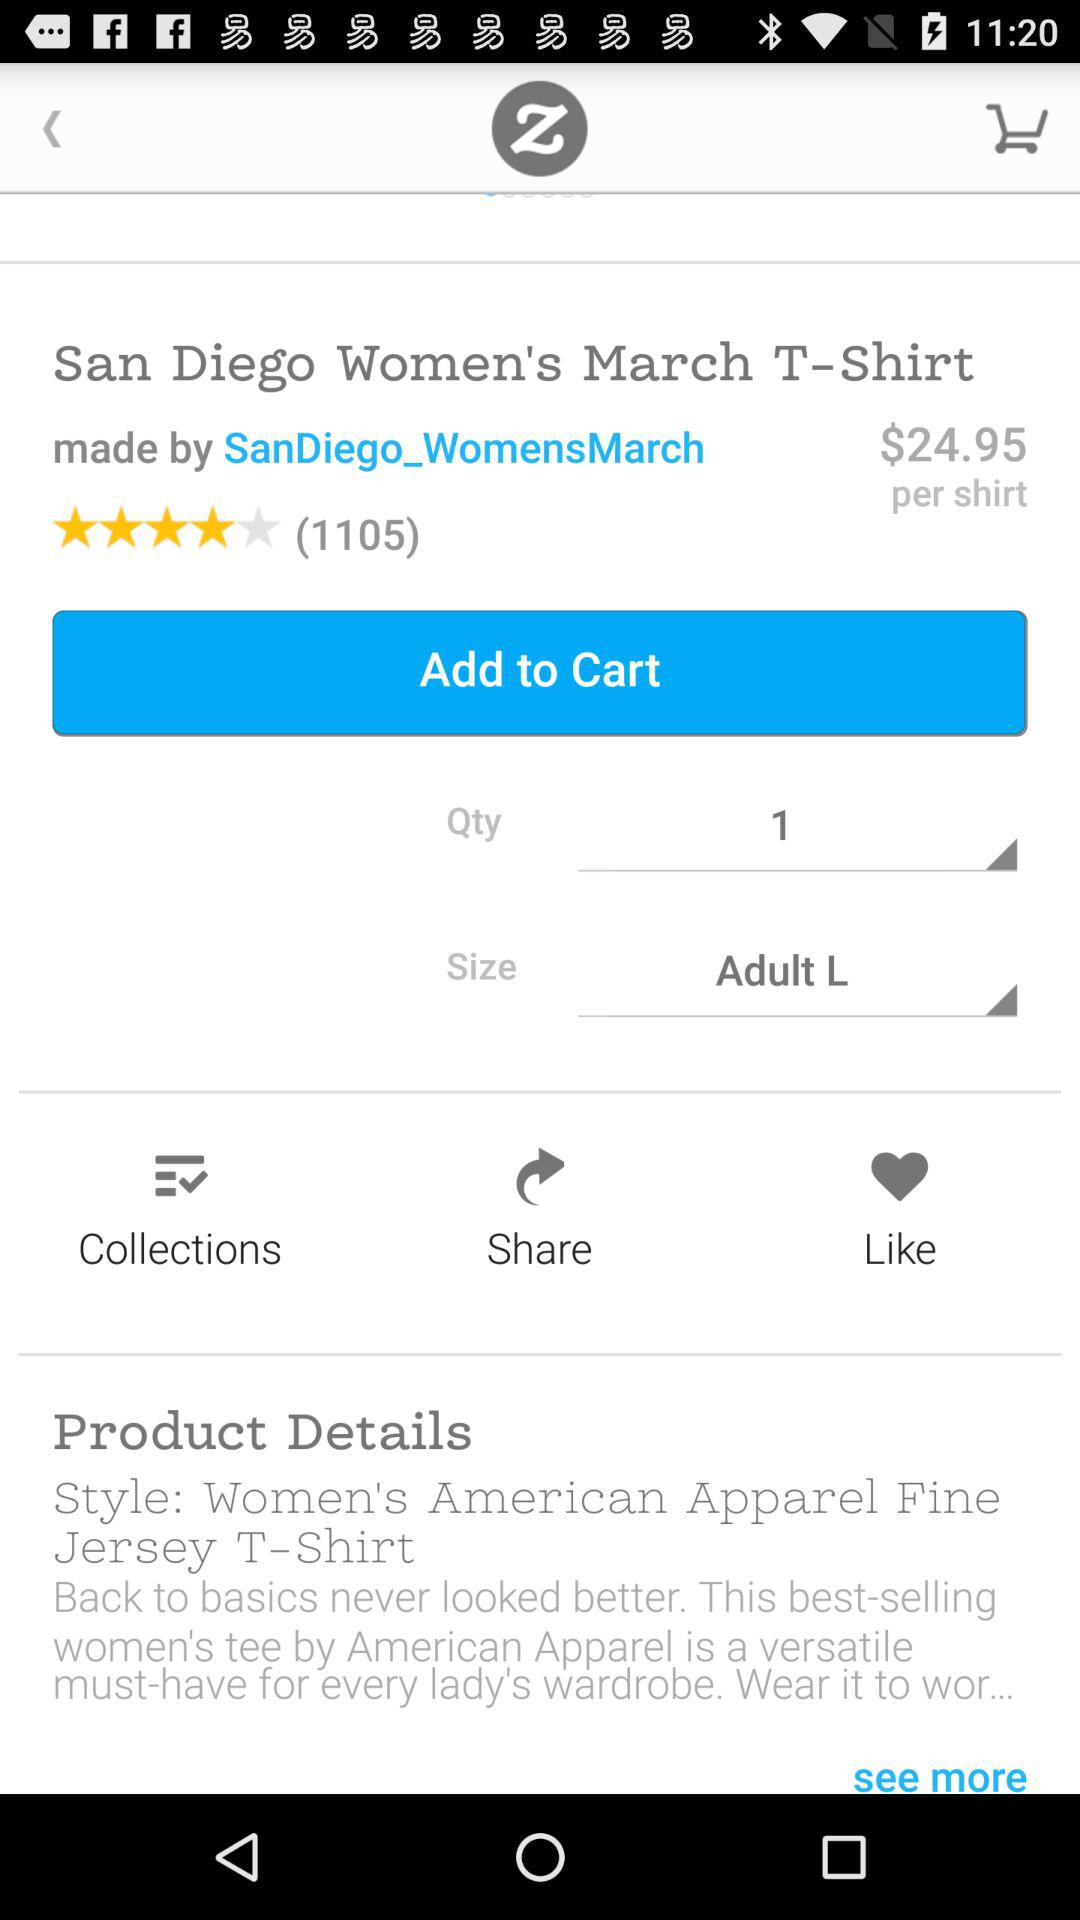What is the selected quantity? The selected quantity is 1. 